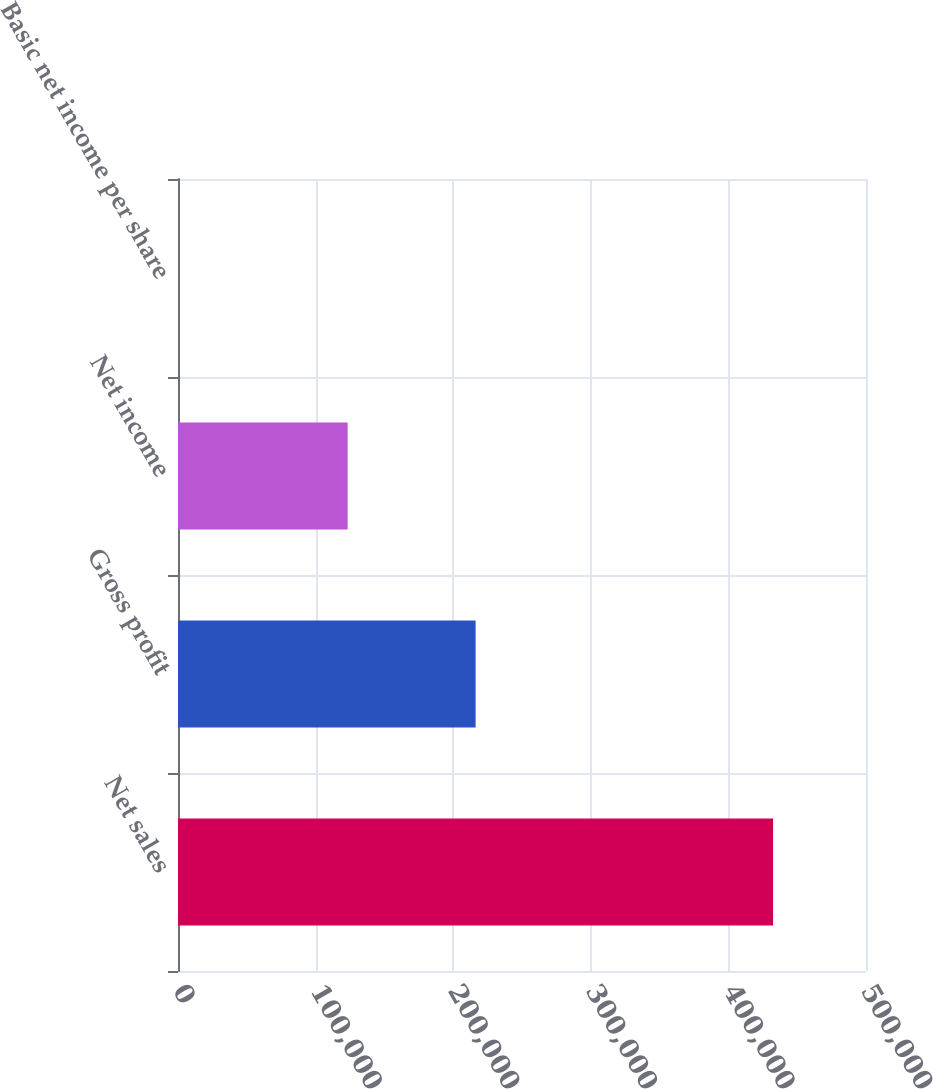Convert chart. <chart><loc_0><loc_0><loc_500><loc_500><bar_chart><fcel>Net sales<fcel>Gross profit<fcel>Net income<fcel>Basic net income per share<nl><fcel>432468<fcel>216284<fcel>123286<fcel>0.57<nl></chart> 